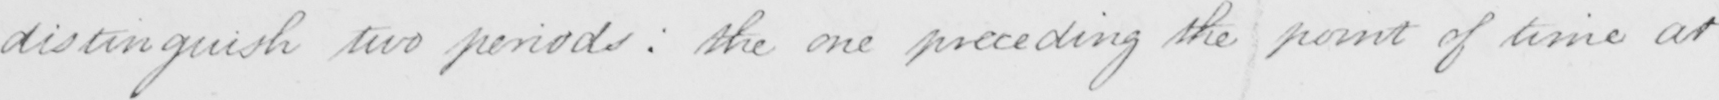Transcribe the text shown in this historical manuscript line. distinguish two periods :  the one preceding the point of time at 